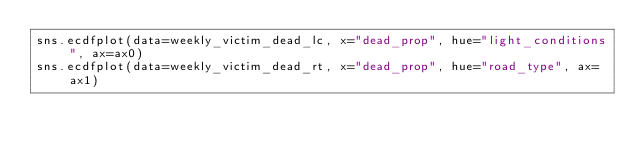Convert code to text. <code><loc_0><loc_0><loc_500><loc_500><_Python_>sns.ecdfplot(data=weekly_victim_dead_lc, x="dead_prop", hue="light_conditions", ax=ax0)
sns.ecdfplot(data=weekly_victim_dead_rt, x="dead_prop", hue="road_type", ax=ax1)</code> 